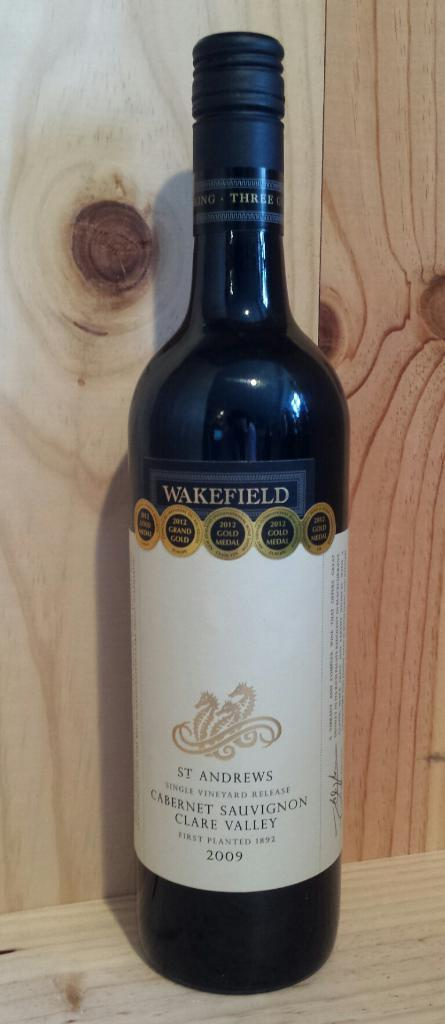<image>
Render a clear and concise summary of the photo. A bottle of cabernet sauvignon is from 2009. 